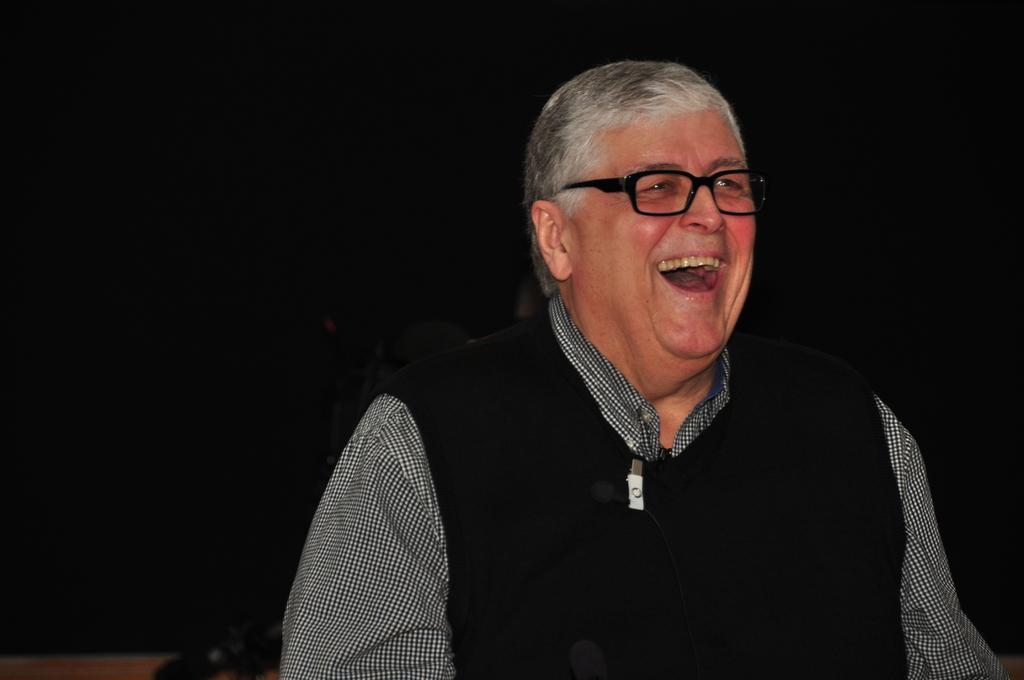How would you summarize this image in a sentence or two? In this image I can see a man is laughing, he is wearing a black color sweater. 